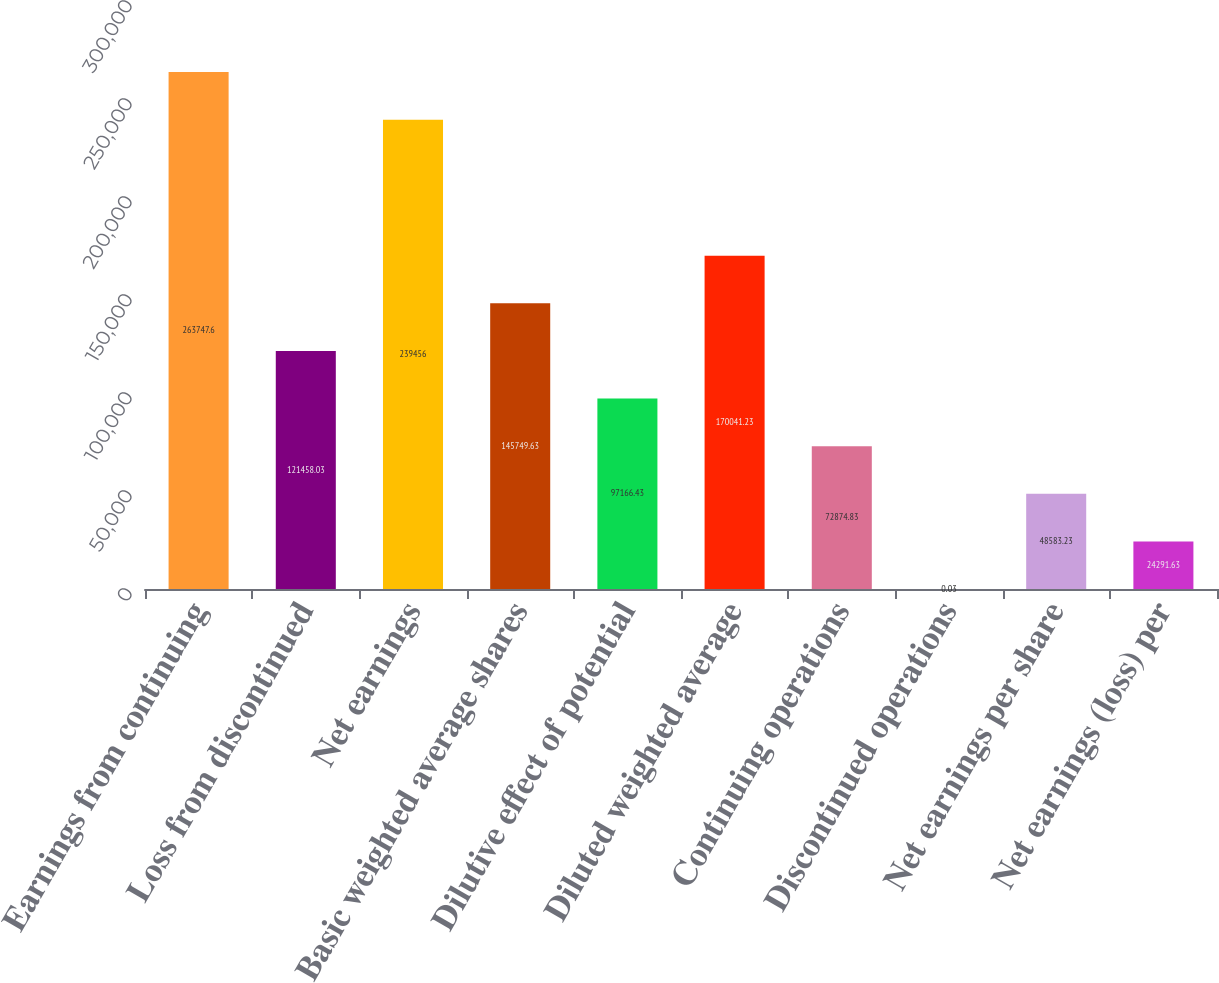Convert chart. <chart><loc_0><loc_0><loc_500><loc_500><bar_chart><fcel>Earnings from continuing<fcel>Loss from discontinued<fcel>Net earnings<fcel>Basic weighted average shares<fcel>Dilutive effect of potential<fcel>Diluted weighted average<fcel>Continuing operations<fcel>Discontinued operations<fcel>Net earnings per share<fcel>Net earnings (loss) per<nl><fcel>263748<fcel>121458<fcel>239456<fcel>145750<fcel>97166.4<fcel>170041<fcel>72874.8<fcel>0.03<fcel>48583.2<fcel>24291.6<nl></chart> 